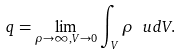Convert formula to latex. <formula><loc_0><loc_0><loc_500><loc_500>q = \lim _ { \rho \rightarrow \infty , V \rightarrow 0 } \int _ { V } \rho \ u d { V } .</formula> 